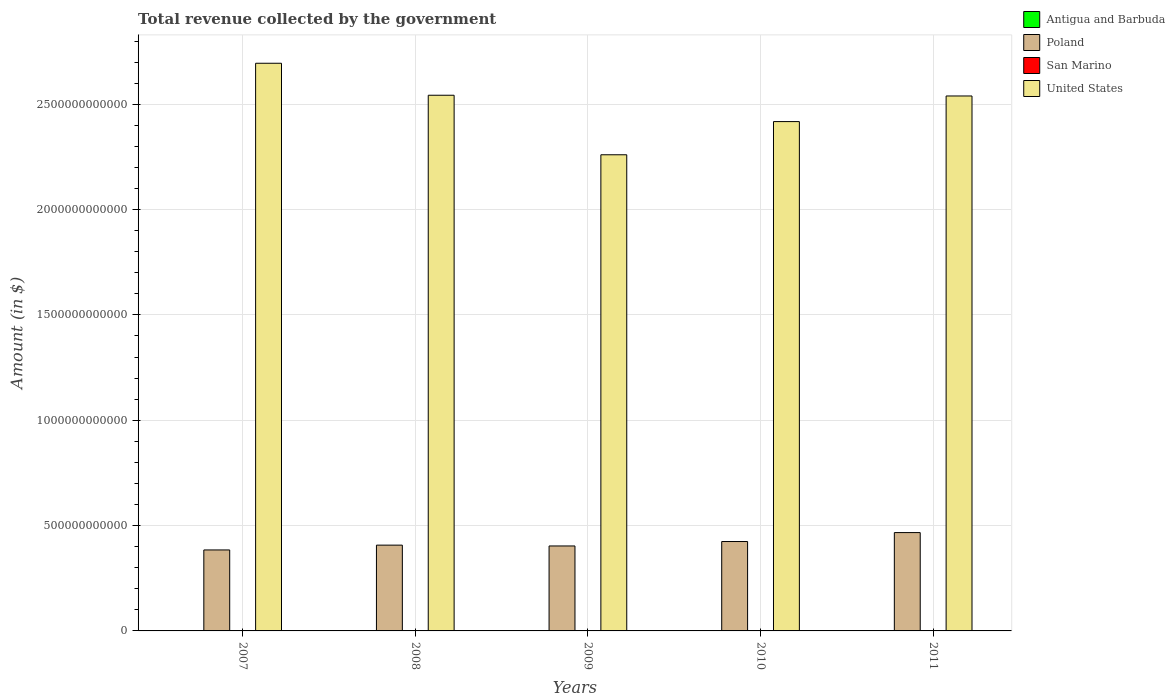How many groups of bars are there?
Provide a short and direct response. 5. How many bars are there on the 4th tick from the right?
Give a very brief answer. 4. What is the label of the 3rd group of bars from the left?
Give a very brief answer. 2009. In how many cases, is the number of bars for a given year not equal to the number of legend labels?
Your answer should be very brief. 0. What is the total revenue collected by the government in San Marino in 2009?
Your answer should be very brief. 5.62e+08. Across all years, what is the maximum total revenue collected by the government in Antigua and Barbuda?
Provide a short and direct response. 7.36e+08. Across all years, what is the minimum total revenue collected by the government in United States?
Your response must be concise. 2.26e+12. What is the total total revenue collected by the government in United States in the graph?
Give a very brief answer. 1.25e+13. What is the difference between the total revenue collected by the government in San Marino in 2009 and that in 2010?
Keep it short and to the point. 3.15e+07. What is the difference between the total revenue collected by the government in United States in 2007 and the total revenue collected by the government in Antigua and Barbuda in 2009?
Ensure brevity in your answer.  2.69e+12. What is the average total revenue collected by the government in United States per year?
Make the answer very short. 2.49e+12. In the year 2008, what is the difference between the total revenue collected by the government in San Marino and total revenue collected by the government in Antigua and Barbuda?
Keep it short and to the point. -1.45e+08. What is the ratio of the total revenue collected by the government in Poland in 2007 to that in 2011?
Offer a very short reply. 0.82. Is the total revenue collected by the government in United States in 2007 less than that in 2010?
Provide a succinct answer. No. Is the difference between the total revenue collected by the government in San Marino in 2007 and 2010 greater than the difference between the total revenue collected by the government in Antigua and Barbuda in 2007 and 2010?
Keep it short and to the point. No. What is the difference between the highest and the second highest total revenue collected by the government in San Marino?
Ensure brevity in your answer.  2.87e+07. What is the difference between the highest and the lowest total revenue collected by the government in United States?
Ensure brevity in your answer.  4.34e+11. What does the 1st bar from the right in 2007 represents?
Ensure brevity in your answer.  United States. Are all the bars in the graph horizontal?
Ensure brevity in your answer.  No. What is the difference between two consecutive major ticks on the Y-axis?
Provide a short and direct response. 5.00e+11. Are the values on the major ticks of Y-axis written in scientific E-notation?
Your response must be concise. No. Does the graph contain any zero values?
Give a very brief answer. No. Does the graph contain grids?
Keep it short and to the point. Yes. Where does the legend appear in the graph?
Keep it short and to the point. Top right. How are the legend labels stacked?
Offer a terse response. Vertical. What is the title of the graph?
Make the answer very short. Total revenue collected by the government. What is the label or title of the Y-axis?
Your response must be concise. Amount (in $). What is the Amount (in $) of Antigua and Barbuda in 2007?
Your answer should be compact. 7.25e+08. What is the Amount (in $) of Poland in 2007?
Your answer should be very brief. 3.84e+11. What is the Amount (in $) of San Marino in 2007?
Your answer should be very brief. 5.60e+08. What is the Amount (in $) in United States in 2007?
Provide a succinct answer. 2.69e+12. What is the Amount (in $) in Antigua and Barbuda in 2008?
Give a very brief answer. 7.36e+08. What is the Amount (in $) in Poland in 2008?
Keep it short and to the point. 4.07e+11. What is the Amount (in $) in San Marino in 2008?
Offer a very short reply. 5.91e+08. What is the Amount (in $) in United States in 2008?
Keep it short and to the point. 2.54e+12. What is the Amount (in $) in Antigua and Barbuda in 2009?
Ensure brevity in your answer.  5.96e+08. What is the Amount (in $) of Poland in 2009?
Give a very brief answer. 4.03e+11. What is the Amount (in $) of San Marino in 2009?
Give a very brief answer. 5.62e+08. What is the Amount (in $) in United States in 2009?
Your answer should be very brief. 2.26e+12. What is the Amount (in $) in Antigua and Barbuda in 2010?
Your response must be concise. 6.40e+08. What is the Amount (in $) of Poland in 2010?
Make the answer very short. 4.24e+11. What is the Amount (in $) in San Marino in 2010?
Make the answer very short. 5.31e+08. What is the Amount (in $) in United States in 2010?
Make the answer very short. 2.42e+12. What is the Amount (in $) of Antigua and Barbuda in 2011?
Keep it short and to the point. 5.96e+08. What is the Amount (in $) in Poland in 2011?
Provide a short and direct response. 4.67e+11. What is the Amount (in $) in San Marino in 2011?
Ensure brevity in your answer.  5.23e+08. What is the Amount (in $) of United States in 2011?
Provide a short and direct response. 2.54e+12. Across all years, what is the maximum Amount (in $) of Antigua and Barbuda?
Provide a succinct answer. 7.36e+08. Across all years, what is the maximum Amount (in $) of Poland?
Offer a very short reply. 4.67e+11. Across all years, what is the maximum Amount (in $) of San Marino?
Give a very brief answer. 5.91e+08. Across all years, what is the maximum Amount (in $) in United States?
Your answer should be very brief. 2.69e+12. Across all years, what is the minimum Amount (in $) of Antigua and Barbuda?
Make the answer very short. 5.96e+08. Across all years, what is the minimum Amount (in $) in Poland?
Offer a very short reply. 3.84e+11. Across all years, what is the minimum Amount (in $) in San Marino?
Offer a terse response. 5.23e+08. Across all years, what is the minimum Amount (in $) in United States?
Give a very brief answer. 2.26e+12. What is the total Amount (in $) in Antigua and Barbuda in the graph?
Make the answer very short. 3.29e+09. What is the total Amount (in $) of Poland in the graph?
Give a very brief answer. 2.09e+12. What is the total Amount (in $) of San Marino in the graph?
Offer a very short reply. 2.77e+09. What is the total Amount (in $) in United States in the graph?
Your response must be concise. 1.25e+13. What is the difference between the Amount (in $) of Antigua and Barbuda in 2007 and that in 2008?
Offer a very short reply. -1.13e+07. What is the difference between the Amount (in $) of Poland in 2007 and that in 2008?
Provide a succinct answer. -2.29e+1. What is the difference between the Amount (in $) of San Marino in 2007 and that in 2008?
Offer a terse response. -3.11e+07. What is the difference between the Amount (in $) of United States in 2007 and that in 2008?
Offer a terse response. 1.52e+11. What is the difference between the Amount (in $) of Antigua and Barbuda in 2007 and that in 2009?
Give a very brief answer. 1.29e+08. What is the difference between the Amount (in $) of Poland in 2007 and that in 2009?
Provide a short and direct response. -1.89e+1. What is the difference between the Amount (in $) of San Marino in 2007 and that in 2009?
Keep it short and to the point. -2.35e+06. What is the difference between the Amount (in $) in United States in 2007 and that in 2009?
Provide a succinct answer. 4.34e+11. What is the difference between the Amount (in $) in Antigua and Barbuda in 2007 and that in 2010?
Give a very brief answer. 8.51e+07. What is the difference between the Amount (in $) of Poland in 2007 and that in 2010?
Ensure brevity in your answer.  -4.00e+1. What is the difference between the Amount (in $) in San Marino in 2007 and that in 2010?
Your response must be concise. 2.91e+07. What is the difference between the Amount (in $) in United States in 2007 and that in 2010?
Keep it short and to the point. 2.77e+11. What is the difference between the Amount (in $) of Antigua and Barbuda in 2007 and that in 2011?
Your response must be concise. 1.28e+08. What is the difference between the Amount (in $) of Poland in 2007 and that in 2011?
Make the answer very short. -8.24e+1. What is the difference between the Amount (in $) of San Marino in 2007 and that in 2011?
Offer a terse response. 3.65e+07. What is the difference between the Amount (in $) of United States in 2007 and that in 2011?
Your answer should be compact. 1.55e+11. What is the difference between the Amount (in $) of Antigua and Barbuda in 2008 and that in 2009?
Your response must be concise. 1.40e+08. What is the difference between the Amount (in $) in Poland in 2008 and that in 2009?
Ensure brevity in your answer.  3.95e+09. What is the difference between the Amount (in $) of San Marino in 2008 and that in 2009?
Make the answer very short. 2.87e+07. What is the difference between the Amount (in $) in United States in 2008 and that in 2009?
Keep it short and to the point. 2.83e+11. What is the difference between the Amount (in $) in Antigua and Barbuda in 2008 and that in 2010?
Offer a terse response. 9.64e+07. What is the difference between the Amount (in $) in Poland in 2008 and that in 2010?
Your response must be concise. -1.71e+1. What is the difference between the Amount (in $) of San Marino in 2008 and that in 2010?
Keep it short and to the point. 6.02e+07. What is the difference between the Amount (in $) of United States in 2008 and that in 2010?
Offer a very short reply. 1.25e+11. What is the difference between the Amount (in $) in Antigua and Barbuda in 2008 and that in 2011?
Offer a terse response. 1.40e+08. What is the difference between the Amount (in $) of Poland in 2008 and that in 2011?
Provide a short and direct response. -5.95e+1. What is the difference between the Amount (in $) in San Marino in 2008 and that in 2011?
Offer a terse response. 6.76e+07. What is the difference between the Amount (in $) of United States in 2008 and that in 2011?
Make the answer very short. 3.50e+09. What is the difference between the Amount (in $) of Antigua and Barbuda in 2009 and that in 2010?
Ensure brevity in your answer.  -4.37e+07. What is the difference between the Amount (in $) of Poland in 2009 and that in 2010?
Your response must be concise. -2.11e+1. What is the difference between the Amount (in $) in San Marino in 2009 and that in 2010?
Make the answer very short. 3.15e+07. What is the difference between the Amount (in $) in United States in 2009 and that in 2010?
Ensure brevity in your answer.  -1.58e+11. What is the difference between the Amount (in $) of Antigua and Barbuda in 2009 and that in 2011?
Give a very brief answer. -4.00e+05. What is the difference between the Amount (in $) in Poland in 2009 and that in 2011?
Provide a short and direct response. -6.35e+1. What is the difference between the Amount (in $) of San Marino in 2009 and that in 2011?
Make the answer very short. 3.89e+07. What is the difference between the Amount (in $) in United States in 2009 and that in 2011?
Provide a short and direct response. -2.79e+11. What is the difference between the Amount (in $) in Antigua and Barbuda in 2010 and that in 2011?
Offer a very short reply. 4.33e+07. What is the difference between the Amount (in $) in Poland in 2010 and that in 2011?
Give a very brief answer. -4.24e+1. What is the difference between the Amount (in $) of San Marino in 2010 and that in 2011?
Make the answer very short. 7.36e+06. What is the difference between the Amount (in $) in United States in 2010 and that in 2011?
Offer a terse response. -1.22e+11. What is the difference between the Amount (in $) in Antigua and Barbuda in 2007 and the Amount (in $) in Poland in 2008?
Offer a terse response. -4.07e+11. What is the difference between the Amount (in $) in Antigua and Barbuda in 2007 and the Amount (in $) in San Marino in 2008?
Your answer should be compact. 1.34e+08. What is the difference between the Amount (in $) of Antigua and Barbuda in 2007 and the Amount (in $) of United States in 2008?
Offer a terse response. -2.54e+12. What is the difference between the Amount (in $) of Poland in 2007 and the Amount (in $) of San Marino in 2008?
Your answer should be compact. 3.84e+11. What is the difference between the Amount (in $) of Poland in 2007 and the Amount (in $) of United States in 2008?
Keep it short and to the point. -2.16e+12. What is the difference between the Amount (in $) of San Marino in 2007 and the Amount (in $) of United States in 2008?
Provide a short and direct response. -2.54e+12. What is the difference between the Amount (in $) in Antigua and Barbuda in 2007 and the Amount (in $) in Poland in 2009?
Your response must be concise. -4.03e+11. What is the difference between the Amount (in $) of Antigua and Barbuda in 2007 and the Amount (in $) of San Marino in 2009?
Provide a short and direct response. 1.63e+08. What is the difference between the Amount (in $) in Antigua and Barbuda in 2007 and the Amount (in $) in United States in 2009?
Provide a succinct answer. -2.26e+12. What is the difference between the Amount (in $) in Poland in 2007 and the Amount (in $) in San Marino in 2009?
Offer a very short reply. 3.84e+11. What is the difference between the Amount (in $) of Poland in 2007 and the Amount (in $) of United States in 2009?
Your answer should be very brief. -1.88e+12. What is the difference between the Amount (in $) in San Marino in 2007 and the Amount (in $) in United States in 2009?
Provide a short and direct response. -2.26e+12. What is the difference between the Amount (in $) in Antigua and Barbuda in 2007 and the Amount (in $) in Poland in 2010?
Provide a short and direct response. -4.24e+11. What is the difference between the Amount (in $) of Antigua and Barbuda in 2007 and the Amount (in $) of San Marino in 2010?
Provide a short and direct response. 1.94e+08. What is the difference between the Amount (in $) in Antigua and Barbuda in 2007 and the Amount (in $) in United States in 2010?
Your answer should be very brief. -2.42e+12. What is the difference between the Amount (in $) of Poland in 2007 and the Amount (in $) of San Marino in 2010?
Ensure brevity in your answer.  3.84e+11. What is the difference between the Amount (in $) of Poland in 2007 and the Amount (in $) of United States in 2010?
Provide a succinct answer. -2.03e+12. What is the difference between the Amount (in $) of San Marino in 2007 and the Amount (in $) of United States in 2010?
Provide a succinct answer. -2.42e+12. What is the difference between the Amount (in $) in Antigua and Barbuda in 2007 and the Amount (in $) in Poland in 2011?
Provide a succinct answer. -4.66e+11. What is the difference between the Amount (in $) of Antigua and Barbuda in 2007 and the Amount (in $) of San Marino in 2011?
Give a very brief answer. 2.01e+08. What is the difference between the Amount (in $) in Antigua and Barbuda in 2007 and the Amount (in $) in United States in 2011?
Offer a very short reply. -2.54e+12. What is the difference between the Amount (in $) of Poland in 2007 and the Amount (in $) of San Marino in 2011?
Give a very brief answer. 3.84e+11. What is the difference between the Amount (in $) in Poland in 2007 and the Amount (in $) in United States in 2011?
Offer a very short reply. -2.15e+12. What is the difference between the Amount (in $) in San Marino in 2007 and the Amount (in $) in United States in 2011?
Ensure brevity in your answer.  -2.54e+12. What is the difference between the Amount (in $) in Antigua and Barbuda in 2008 and the Amount (in $) in Poland in 2009?
Provide a short and direct response. -4.03e+11. What is the difference between the Amount (in $) of Antigua and Barbuda in 2008 and the Amount (in $) of San Marino in 2009?
Your answer should be compact. 1.74e+08. What is the difference between the Amount (in $) in Antigua and Barbuda in 2008 and the Amount (in $) in United States in 2009?
Provide a short and direct response. -2.26e+12. What is the difference between the Amount (in $) of Poland in 2008 and the Amount (in $) of San Marino in 2009?
Your answer should be very brief. 4.07e+11. What is the difference between the Amount (in $) in Poland in 2008 and the Amount (in $) in United States in 2009?
Your answer should be compact. -1.85e+12. What is the difference between the Amount (in $) in San Marino in 2008 and the Amount (in $) in United States in 2009?
Give a very brief answer. -2.26e+12. What is the difference between the Amount (in $) in Antigua and Barbuda in 2008 and the Amount (in $) in Poland in 2010?
Provide a short and direct response. -4.24e+11. What is the difference between the Amount (in $) in Antigua and Barbuda in 2008 and the Amount (in $) in San Marino in 2010?
Offer a terse response. 2.05e+08. What is the difference between the Amount (in $) in Antigua and Barbuda in 2008 and the Amount (in $) in United States in 2010?
Your response must be concise. -2.42e+12. What is the difference between the Amount (in $) in Poland in 2008 and the Amount (in $) in San Marino in 2010?
Give a very brief answer. 4.07e+11. What is the difference between the Amount (in $) of Poland in 2008 and the Amount (in $) of United States in 2010?
Keep it short and to the point. -2.01e+12. What is the difference between the Amount (in $) in San Marino in 2008 and the Amount (in $) in United States in 2010?
Your answer should be compact. -2.42e+12. What is the difference between the Amount (in $) of Antigua and Barbuda in 2008 and the Amount (in $) of Poland in 2011?
Your answer should be very brief. -4.66e+11. What is the difference between the Amount (in $) in Antigua and Barbuda in 2008 and the Amount (in $) in San Marino in 2011?
Make the answer very short. 2.13e+08. What is the difference between the Amount (in $) of Antigua and Barbuda in 2008 and the Amount (in $) of United States in 2011?
Offer a very short reply. -2.54e+12. What is the difference between the Amount (in $) in Poland in 2008 and the Amount (in $) in San Marino in 2011?
Provide a succinct answer. 4.07e+11. What is the difference between the Amount (in $) in Poland in 2008 and the Amount (in $) in United States in 2011?
Give a very brief answer. -2.13e+12. What is the difference between the Amount (in $) in San Marino in 2008 and the Amount (in $) in United States in 2011?
Your answer should be very brief. -2.54e+12. What is the difference between the Amount (in $) of Antigua and Barbuda in 2009 and the Amount (in $) of Poland in 2010?
Ensure brevity in your answer.  -4.24e+11. What is the difference between the Amount (in $) in Antigua and Barbuda in 2009 and the Amount (in $) in San Marino in 2010?
Ensure brevity in your answer.  6.52e+07. What is the difference between the Amount (in $) in Antigua and Barbuda in 2009 and the Amount (in $) in United States in 2010?
Your response must be concise. -2.42e+12. What is the difference between the Amount (in $) of Poland in 2009 and the Amount (in $) of San Marino in 2010?
Your answer should be very brief. 4.03e+11. What is the difference between the Amount (in $) of Poland in 2009 and the Amount (in $) of United States in 2010?
Offer a terse response. -2.01e+12. What is the difference between the Amount (in $) of San Marino in 2009 and the Amount (in $) of United States in 2010?
Provide a succinct answer. -2.42e+12. What is the difference between the Amount (in $) in Antigua and Barbuda in 2009 and the Amount (in $) in Poland in 2011?
Give a very brief answer. -4.66e+11. What is the difference between the Amount (in $) of Antigua and Barbuda in 2009 and the Amount (in $) of San Marino in 2011?
Your answer should be compact. 7.26e+07. What is the difference between the Amount (in $) in Antigua and Barbuda in 2009 and the Amount (in $) in United States in 2011?
Your response must be concise. -2.54e+12. What is the difference between the Amount (in $) in Poland in 2009 and the Amount (in $) in San Marino in 2011?
Offer a very short reply. 4.03e+11. What is the difference between the Amount (in $) of Poland in 2009 and the Amount (in $) of United States in 2011?
Keep it short and to the point. -2.14e+12. What is the difference between the Amount (in $) in San Marino in 2009 and the Amount (in $) in United States in 2011?
Your answer should be compact. -2.54e+12. What is the difference between the Amount (in $) in Antigua and Barbuda in 2010 and the Amount (in $) in Poland in 2011?
Make the answer very short. -4.66e+11. What is the difference between the Amount (in $) in Antigua and Barbuda in 2010 and the Amount (in $) in San Marino in 2011?
Keep it short and to the point. 1.16e+08. What is the difference between the Amount (in $) in Antigua and Barbuda in 2010 and the Amount (in $) in United States in 2011?
Your answer should be compact. -2.54e+12. What is the difference between the Amount (in $) of Poland in 2010 and the Amount (in $) of San Marino in 2011?
Your answer should be compact. 4.24e+11. What is the difference between the Amount (in $) in Poland in 2010 and the Amount (in $) in United States in 2011?
Offer a very short reply. -2.11e+12. What is the difference between the Amount (in $) of San Marino in 2010 and the Amount (in $) of United States in 2011?
Your answer should be compact. -2.54e+12. What is the average Amount (in $) in Antigua and Barbuda per year?
Your answer should be compact. 6.58e+08. What is the average Amount (in $) in Poland per year?
Ensure brevity in your answer.  4.17e+11. What is the average Amount (in $) of San Marino per year?
Provide a short and direct response. 5.53e+08. What is the average Amount (in $) in United States per year?
Provide a succinct answer. 2.49e+12. In the year 2007, what is the difference between the Amount (in $) of Antigua and Barbuda and Amount (in $) of Poland?
Your response must be concise. -3.84e+11. In the year 2007, what is the difference between the Amount (in $) of Antigua and Barbuda and Amount (in $) of San Marino?
Provide a short and direct response. 1.65e+08. In the year 2007, what is the difference between the Amount (in $) in Antigua and Barbuda and Amount (in $) in United States?
Your answer should be compact. -2.69e+12. In the year 2007, what is the difference between the Amount (in $) in Poland and Amount (in $) in San Marino?
Offer a terse response. 3.84e+11. In the year 2007, what is the difference between the Amount (in $) of Poland and Amount (in $) of United States?
Make the answer very short. -2.31e+12. In the year 2007, what is the difference between the Amount (in $) in San Marino and Amount (in $) in United States?
Keep it short and to the point. -2.69e+12. In the year 2008, what is the difference between the Amount (in $) in Antigua and Barbuda and Amount (in $) in Poland?
Offer a very short reply. -4.07e+11. In the year 2008, what is the difference between the Amount (in $) in Antigua and Barbuda and Amount (in $) in San Marino?
Make the answer very short. 1.45e+08. In the year 2008, what is the difference between the Amount (in $) in Antigua and Barbuda and Amount (in $) in United States?
Your answer should be compact. -2.54e+12. In the year 2008, what is the difference between the Amount (in $) in Poland and Amount (in $) in San Marino?
Your answer should be very brief. 4.07e+11. In the year 2008, what is the difference between the Amount (in $) of Poland and Amount (in $) of United States?
Offer a terse response. -2.14e+12. In the year 2008, what is the difference between the Amount (in $) of San Marino and Amount (in $) of United States?
Give a very brief answer. -2.54e+12. In the year 2009, what is the difference between the Amount (in $) in Antigua and Barbuda and Amount (in $) in Poland?
Ensure brevity in your answer.  -4.03e+11. In the year 2009, what is the difference between the Amount (in $) in Antigua and Barbuda and Amount (in $) in San Marino?
Ensure brevity in your answer.  3.37e+07. In the year 2009, what is the difference between the Amount (in $) in Antigua and Barbuda and Amount (in $) in United States?
Your response must be concise. -2.26e+12. In the year 2009, what is the difference between the Amount (in $) of Poland and Amount (in $) of San Marino?
Ensure brevity in your answer.  4.03e+11. In the year 2009, what is the difference between the Amount (in $) in Poland and Amount (in $) in United States?
Ensure brevity in your answer.  -1.86e+12. In the year 2009, what is the difference between the Amount (in $) in San Marino and Amount (in $) in United States?
Your response must be concise. -2.26e+12. In the year 2010, what is the difference between the Amount (in $) in Antigua and Barbuda and Amount (in $) in Poland?
Your response must be concise. -4.24e+11. In the year 2010, what is the difference between the Amount (in $) of Antigua and Barbuda and Amount (in $) of San Marino?
Make the answer very short. 1.09e+08. In the year 2010, what is the difference between the Amount (in $) in Antigua and Barbuda and Amount (in $) in United States?
Provide a short and direct response. -2.42e+12. In the year 2010, what is the difference between the Amount (in $) of Poland and Amount (in $) of San Marino?
Provide a succinct answer. 4.24e+11. In the year 2010, what is the difference between the Amount (in $) in Poland and Amount (in $) in United States?
Provide a succinct answer. -1.99e+12. In the year 2010, what is the difference between the Amount (in $) in San Marino and Amount (in $) in United States?
Your answer should be very brief. -2.42e+12. In the year 2011, what is the difference between the Amount (in $) of Antigua and Barbuda and Amount (in $) of Poland?
Provide a short and direct response. -4.66e+11. In the year 2011, what is the difference between the Amount (in $) in Antigua and Barbuda and Amount (in $) in San Marino?
Keep it short and to the point. 7.30e+07. In the year 2011, what is the difference between the Amount (in $) in Antigua and Barbuda and Amount (in $) in United States?
Provide a succinct answer. -2.54e+12. In the year 2011, what is the difference between the Amount (in $) in Poland and Amount (in $) in San Marino?
Your response must be concise. 4.66e+11. In the year 2011, what is the difference between the Amount (in $) in Poland and Amount (in $) in United States?
Provide a succinct answer. -2.07e+12. In the year 2011, what is the difference between the Amount (in $) of San Marino and Amount (in $) of United States?
Offer a terse response. -2.54e+12. What is the ratio of the Amount (in $) in Antigua and Barbuda in 2007 to that in 2008?
Ensure brevity in your answer.  0.98. What is the ratio of the Amount (in $) in Poland in 2007 to that in 2008?
Your answer should be compact. 0.94. What is the ratio of the Amount (in $) of San Marino in 2007 to that in 2008?
Ensure brevity in your answer.  0.95. What is the ratio of the Amount (in $) in United States in 2007 to that in 2008?
Your answer should be compact. 1.06. What is the ratio of the Amount (in $) of Antigua and Barbuda in 2007 to that in 2009?
Your answer should be compact. 1.22. What is the ratio of the Amount (in $) of Poland in 2007 to that in 2009?
Give a very brief answer. 0.95. What is the ratio of the Amount (in $) of San Marino in 2007 to that in 2009?
Ensure brevity in your answer.  1. What is the ratio of the Amount (in $) of United States in 2007 to that in 2009?
Offer a terse response. 1.19. What is the ratio of the Amount (in $) of Antigua and Barbuda in 2007 to that in 2010?
Your answer should be compact. 1.13. What is the ratio of the Amount (in $) of Poland in 2007 to that in 2010?
Give a very brief answer. 0.91. What is the ratio of the Amount (in $) in San Marino in 2007 to that in 2010?
Give a very brief answer. 1.05. What is the ratio of the Amount (in $) in United States in 2007 to that in 2010?
Ensure brevity in your answer.  1.11. What is the ratio of the Amount (in $) of Antigua and Barbuda in 2007 to that in 2011?
Provide a succinct answer. 1.22. What is the ratio of the Amount (in $) of Poland in 2007 to that in 2011?
Ensure brevity in your answer.  0.82. What is the ratio of the Amount (in $) of San Marino in 2007 to that in 2011?
Make the answer very short. 1.07. What is the ratio of the Amount (in $) of United States in 2007 to that in 2011?
Your response must be concise. 1.06. What is the ratio of the Amount (in $) in Antigua and Barbuda in 2008 to that in 2009?
Keep it short and to the point. 1.24. What is the ratio of the Amount (in $) of Poland in 2008 to that in 2009?
Your answer should be compact. 1.01. What is the ratio of the Amount (in $) of San Marino in 2008 to that in 2009?
Make the answer very short. 1.05. What is the ratio of the Amount (in $) of United States in 2008 to that in 2009?
Provide a succinct answer. 1.12. What is the ratio of the Amount (in $) of Antigua and Barbuda in 2008 to that in 2010?
Ensure brevity in your answer.  1.15. What is the ratio of the Amount (in $) in Poland in 2008 to that in 2010?
Keep it short and to the point. 0.96. What is the ratio of the Amount (in $) of San Marino in 2008 to that in 2010?
Your response must be concise. 1.11. What is the ratio of the Amount (in $) of United States in 2008 to that in 2010?
Keep it short and to the point. 1.05. What is the ratio of the Amount (in $) in Antigua and Barbuda in 2008 to that in 2011?
Your response must be concise. 1.23. What is the ratio of the Amount (in $) in Poland in 2008 to that in 2011?
Give a very brief answer. 0.87. What is the ratio of the Amount (in $) in San Marino in 2008 to that in 2011?
Provide a short and direct response. 1.13. What is the ratio of the Amount (in $) of Antigua and Barbuda in 2009 to that in 2010?
Offer a very short reply. 0.93. What is the ratio of the Amount (in $) of Poland in 2009 to that in 2010?
Your answer should be compact. 0.95. What is the ratio of the Amount (in $) in San Marino in 2009 to that in 2010?
Provide a short and direct response. 1.06. What is the ratio of the Amount (in $) of United States in 2009 to that in 2010?
Provide a succinct answer. 0.93. What is the ratio of the Amount (in $) of Antigua and Barbuda in 2009 to that in 2011?
Your answer should be compact. 1. What is the ratio of the Amount (in $) in Poland in 2009 to that in 2011?
Your answer should be compact. 0.86. What is the ratio of the Amount (in $) in San Marino in 2009 to that in 2011?
Give a very brief answer. 1.07. What is the ratio of the Amount (in $) in United States in 2009 to that in 2011?
Provide a short and direct response. 0.89. What is the ratio of the Amount (in $) in Antigua and Barbuda in 2010 to that in 2011?
Your answer should be compact. 1.07. What is the ratio of the Amount (in $) of San Marino in 2010 to that in 2011?
Your answer should be very brief. 1.01. What is the ratio of the Amount (in $) in United States in 2010 to that in 2011?
Your answer should be compact. 0.95. What is the difference between the highest and the second highest Amount (in $) in Antigua and Barbuda?
Your answer should be compact. 1.13e+07. What is the difference between the highest and the second highest Amount (in $) of Poland?
Provide a succinct answer. 4.24e+1. What is the difference between the highest and the second highest Amount (in $) in San Marino?
Your answer should be compact. 2.87e+07. What is the difference between the highest and the second highest Amount (in $) in United States?
Provide a succinct answer. 1.52e+11. What is the difference between the highest and the lowest Amount (in $) of Antigua and Barbuda?
Your answer should be compact. 1.40e+08. What is the difference between the highest and the lowest Amount (in $) of Poland?
Offer a very short reply. 8.24e+1. What is the difference between the highest and the lowest Amount (in $) in San Marino?
Give a very brief answer. 6.76e+07. What is the difference between the highest and the lowest Amount (in $) in United States?
Your answer should be compact. 4.34e+11. 